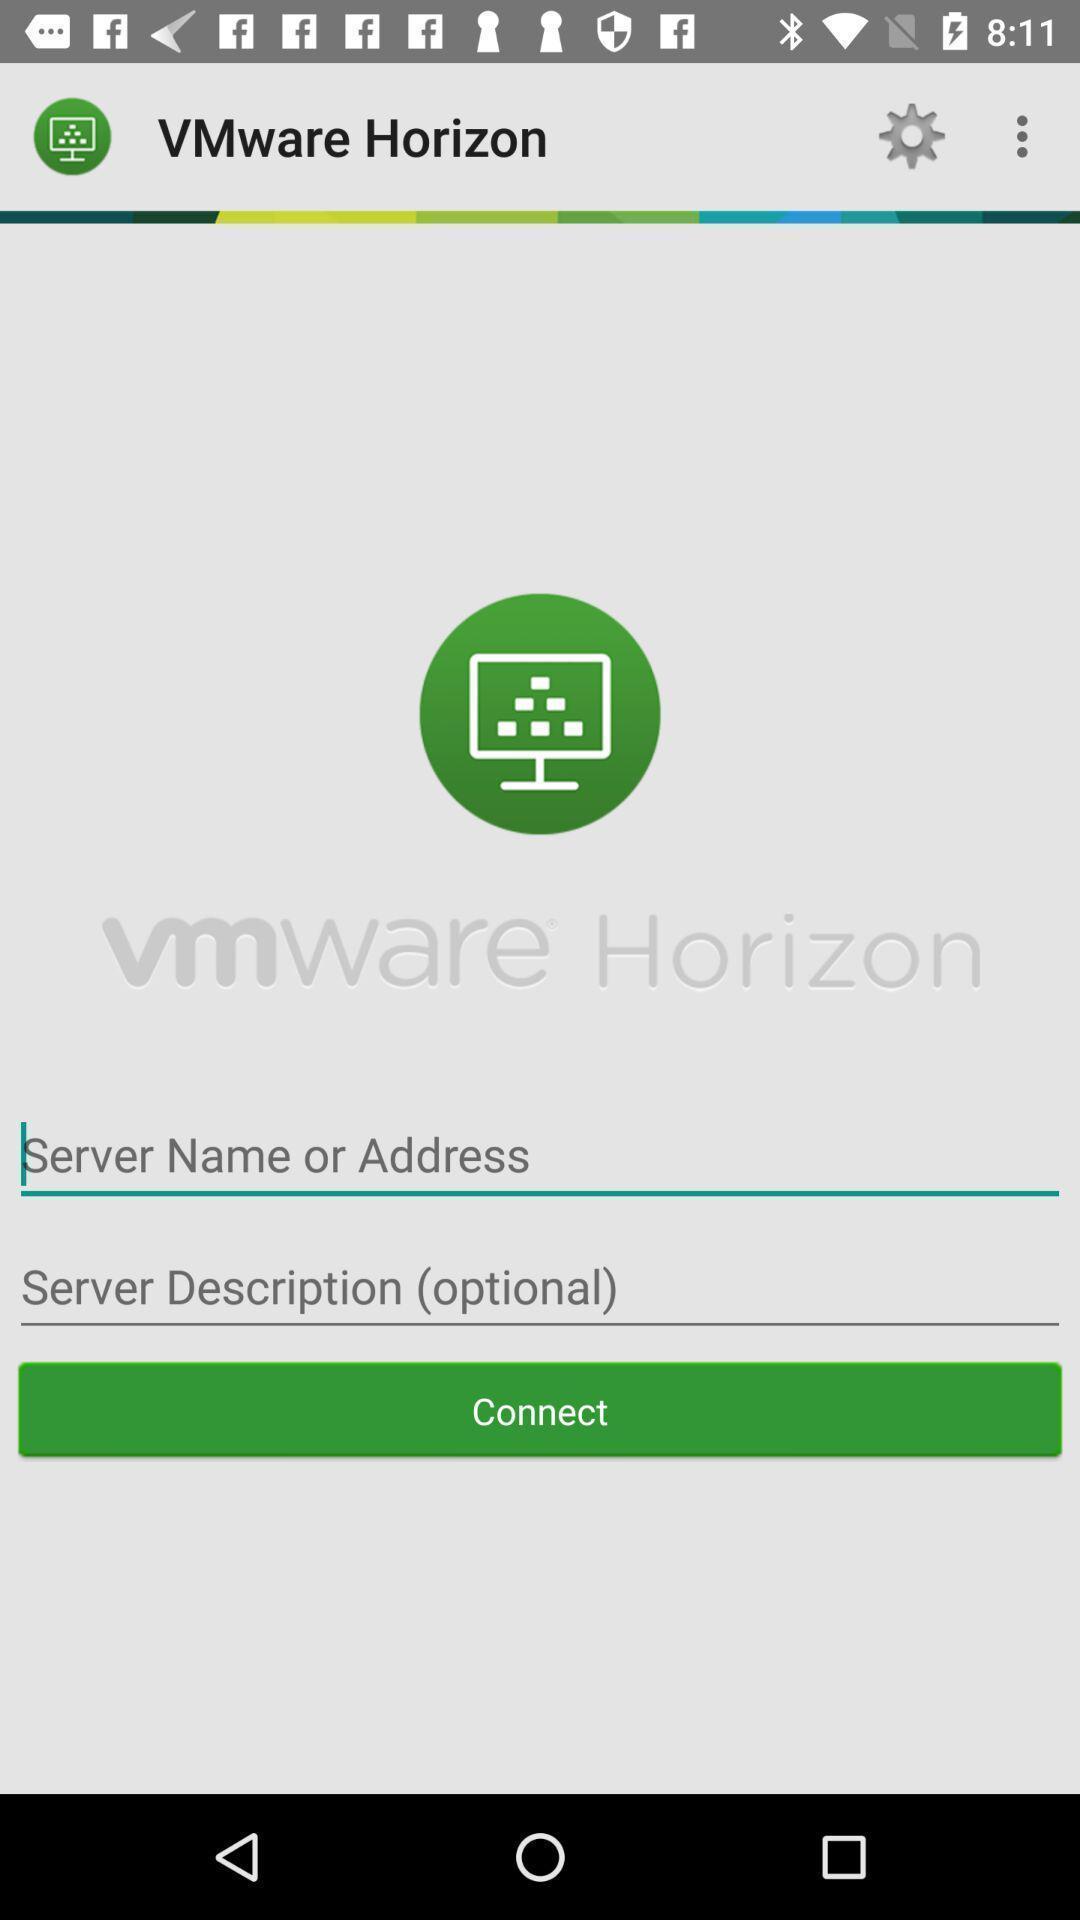Give me a narrative description of this picture. Screen displaying multiple setting options in a virtual platform application. 